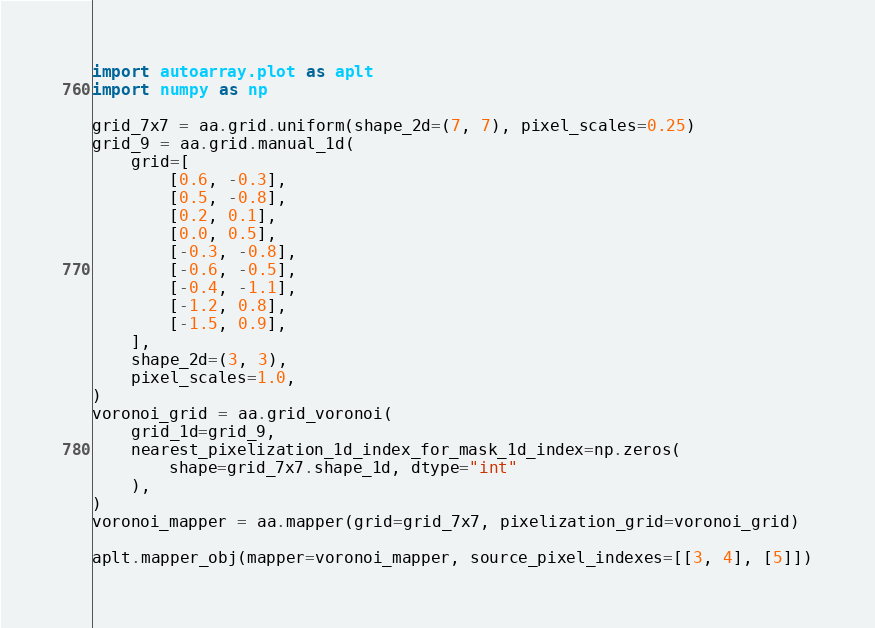<code> <loc_0><loc_0><loc_500><loc_500><_Python_>import autoarray.plot as aplt
import numpy as np

grid_7x7 = aa.grid.uniform(shape_2d=(7, 7), pixel_scales=0.25)
grid_9 = aa.grid.manual_1d(
    grid=[
        [0.6, -0.3],
        [0.5, -0.8],
        [0.2, 0.1],
        [0.0, 0.5],
        [-0.3, -0.8],
        [-0.6, -0.5],
        [-0.4, -1.1],
        [-1.2, 0.8],
        [-1.5, 0.9],
    ],
    shape_2d=(3, 3),
    pixel_scales=1.0,
)
voronoi_grid = aa.grid_voronoi(
    grid_1d=grid_9,
    nearest_pixelization_1d_index_for_mask_1d_index=np.zeros(
        shape=grid_7x7.shape_1d, dtype="int"
    ),
)
voronoi_mapper = aa.mapper(grid=grid_7x7, pixelization_grid=voronoi_grid)

aplt.mapper_obj(mapper=voronoi_mapper, source_pixel_indexes=[[3, 4], [5]])
</code> 